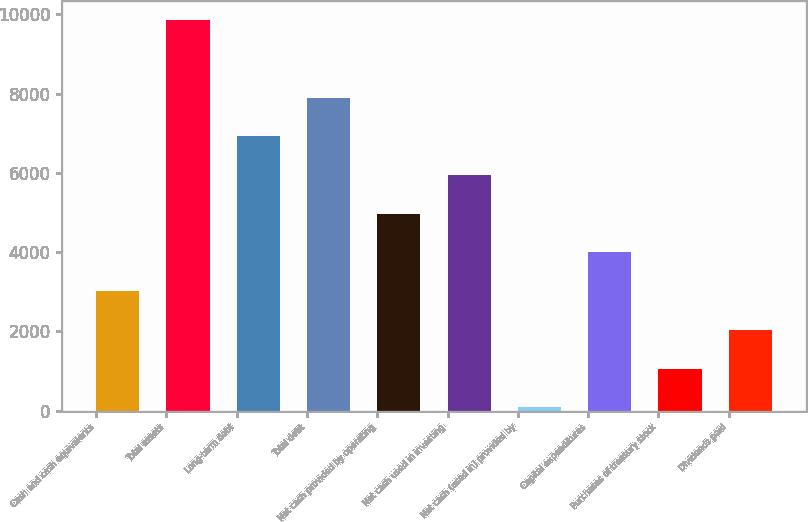Convert chart to OTSL. <chart><loc_0><loc_0><loc_500><loc_500><bar_chart><fcel>Cash and cash equivalents<fcel>Total assets<fcel>Long-term debt<fcel>Total debt<fcel>Net cash provided by operating<fcel>Net cash used in investing<fcel>Net cash (used in) provided by<fcel>Capital expenditures<fcel>Purchases of treasury stock<fcel>Dividends paid<nl><fcel>3017.3<fcel>9857<fcel>6925.7<fcel>7902.8<fcel>4971.5<fcel>5948.6<fcel>86<fcel>3994.4<fcel>1063.1<fcel>2040.2<nl></chart> 